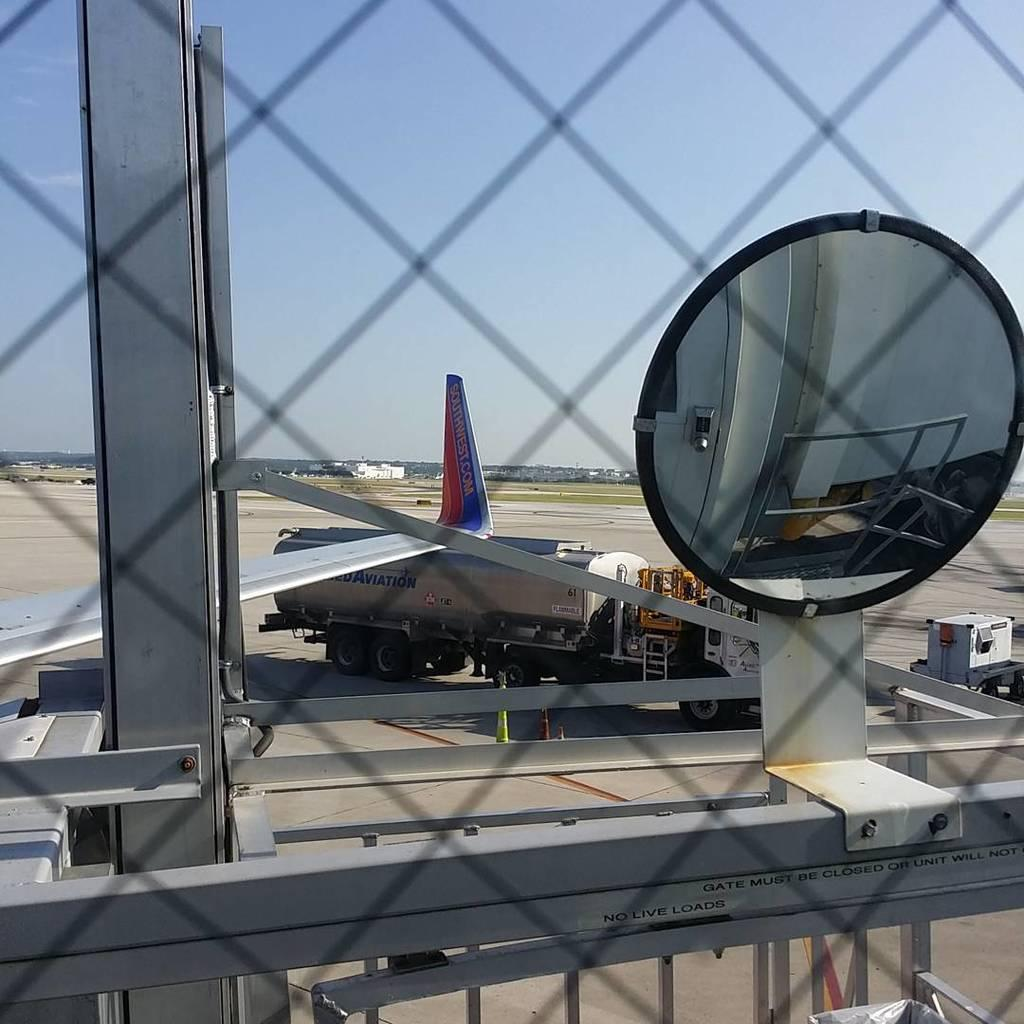<image>
Share a concise interpretation of the image provided. An airplane is on the tarmac and the wing says "Southwest.com." 